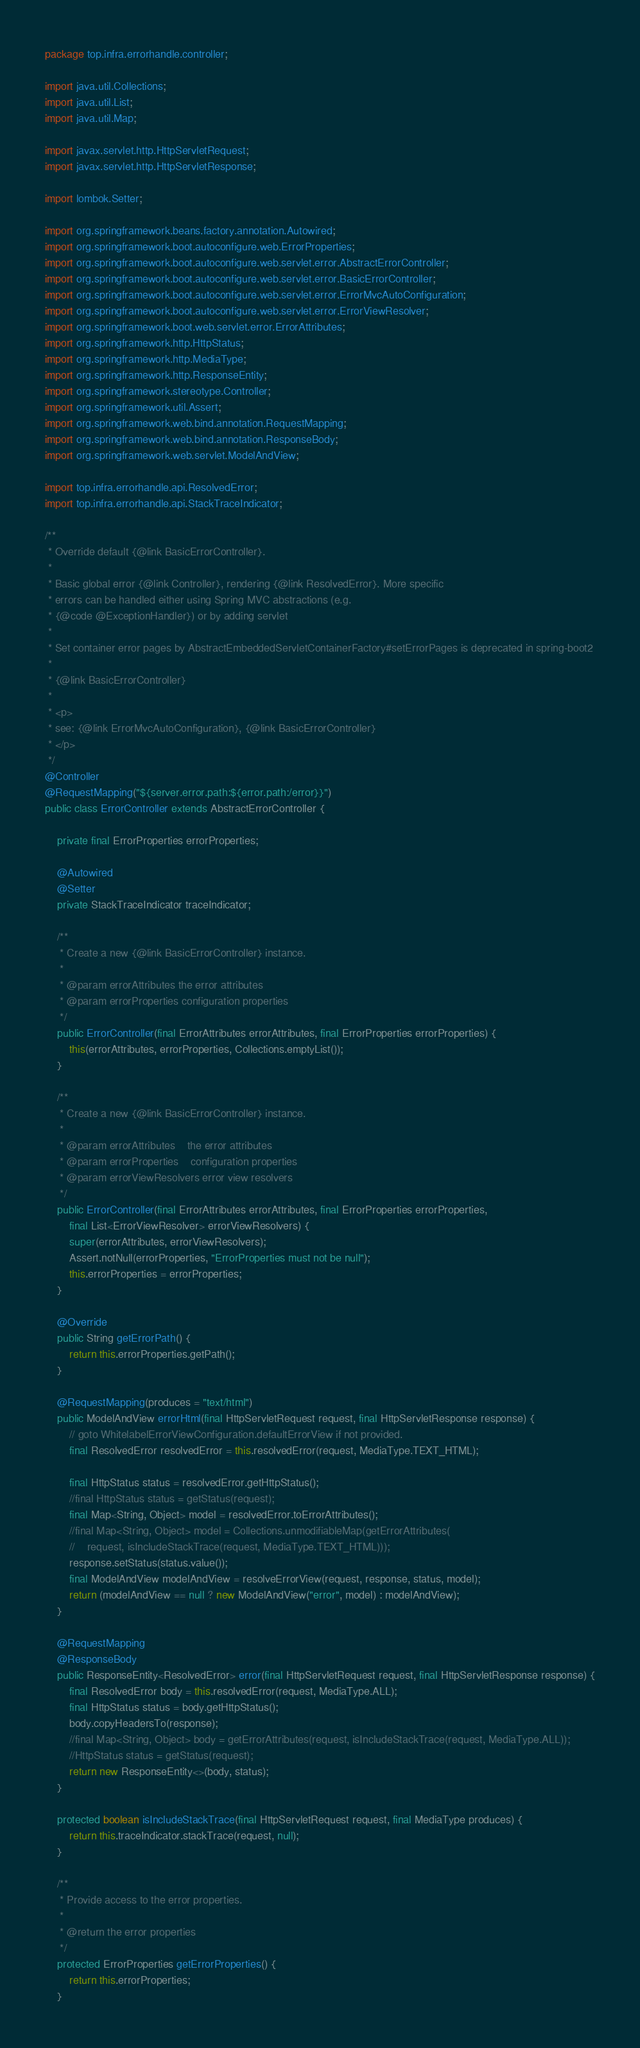<code> <loc_0><loc_0><loc_500><loc_500><_Java_>package top.infra.errorhandle.controller;

import java.util.Collections;
import java.util.List;
import java.util.Map;

import javax.servlet.http.HttpServletRequest;
import javax.servlet.http.HttpServletResponse;

import lombok.Setter;

import org.springframework.beans.factory.annotation.Autowired;
import org.springframework.boot.autoconfigure.web.ErrorProperties;
import org.springframework.boot.autoconfigure.web.servlet.error.AbstractErrorController;
import org.springframework.boot.autoconfigure.web.servlet.error.BasicErrorController;
import org.springframework.boot.autoconfigure.web.servlet.error.ErrorMvcAutoConfiguration;
import org.springframework.boot.autoconfigure.web.servlet.error.ErrorViewResolver;
import org.springframework.boot.web.servlet.error.ErrorAttributes;
import org.springframework.http.HttpStatus;
import org.springframework.http.MediaType;
import org.springframework.http.ResponseEntity;
import org.springframework.stereotype.Controller;
import org.springframework.util.Assert;
import org.springframework.web.bind.annotation.RequestMapping;
import org.springframework.web.bind.annotation.ResponseBody;
import org.springframework.web.servlet.ModelAndView;

import top.infra.errorhandle.api.ResolvedError;
import top.infra.errorhandle.api.StackTraceIndicator;

/**
 * Override default {@link BasicErrorController}.
 *
 * Basic global error {@link Controller}, rendering {@link ResolvedError}. More specific
 * errors can be handled either using Spring MVC abstractions (e.g.
 * {@code @ExceptionHandler}) or by adding servlet
 *
 * Set container error pages by AbstractEmbeddedServletContainerFactory#setErrorPages is deprecated in spring-boot2
 *
 * {@link BasicErrorController}
 *
 * <p>
 * see: {@link ErrorMvcAutoConfiguration}, {@link BasicErrorController}
 * </p>
 */
@Controller
@RequestMapping("${server.error.path:${error.path:/error}}")
public class ErrorController extends AbstractErrorController {

    private final ErrorProperties errorProperties;

    @Autowired
    @Setter
    private StackTraceIndicator traceIndicator;

    /**
     * Create a new {@link BasicErrorController} instance.
     *
     * @param errorAttributes the error attributes
     * @param errorProperties configuration properties
     */
    public ErrorController(final ErrorAttributes errorAttributes, final ErrorProperties errorProperties) {
        this(errorAttributes, errorProperties, Collections.emptyList());
    }

    /**
     * Create a new {@link BasicErrorController} instance.
     *
     * @param errorAttributes    the error attributes
     * @param errorProperties    configuration properties
     * @param errorViewResolvers error view resolvers
     */
    public ErrorController(final ErrorAttributes errorAttributes, final ErrorProperties errorProperties,
        final List<ErrorViewResolver> errorViewResolvers) {
        super(errorAttributes, errorViewResolvers);
        Assert.notNull(errorProperties, "ErrorProperties must not be null");
        this.errorProperties = errorProperties;
    }

    @Override
    public String getErrorPath() {
        return this.errorProperties.getPath();
    }

    @RequestMapping(produces = "text/html")
    public ModelAndView errorHtml(final HttpServletRequest request, final HttpServletResponse response) {
        // goto WhitelabelErrorViewConfiguration.defaultErrorView if not provided.
        final ResolvedError resolvedError = this.resolvedError(request, MediaType.TEXT_HTML);

        final HttpStatus status = resolvedError.getHttpStatus();
        //final HttpStatus status = getStatus(request);
        final Map<String, Object> model = resolvedError.toErrorAttributes();
        //final Map<String, Object> model = Collections.unmodifiableMap(getErrorAttributes(
        //    request, isIncludeStackTrace(request, MediaType.TEXT_HTML)));
        response.setStatus(status.value());
        final ModelAndView modelAndView = resolveErrorView(request, response, status, model);
        return (modelAndView == null ? new ModelAndView("error", model) : modelAndView);
    }

    @RequestMapping
    @ResponseBody
    public ResponseEntity<ResolvedError> error(final HttpServletRequest request, final HttpServletResponse response) {
        final ResolvedError body = this.resolvedError(request, MediaType.ALL);
        final HttpStatus status = body.getHttpStatus();
        body.copyHeadersTo(response);
        //final Map<String, Object> body = getErrorAttributes(request, isIncludeStackTrace(request, MediaType.ALL));
        //HttpStatus status = getStatus(request);
        return new ResponseEntity<>(body, status);
    }

    protected boolean isIncludeStackTrace(final HttpServletRequest request, final MediaType produces) {
        return this.traceIndicator.stackTrace(request, null);
    }

    /**
     * Provide access to the error properties.
     *
     * @return the error properties
     */
    protected ErrorProperties getErrorProperties() {
        return this.errorProperties;
    }
</code> 